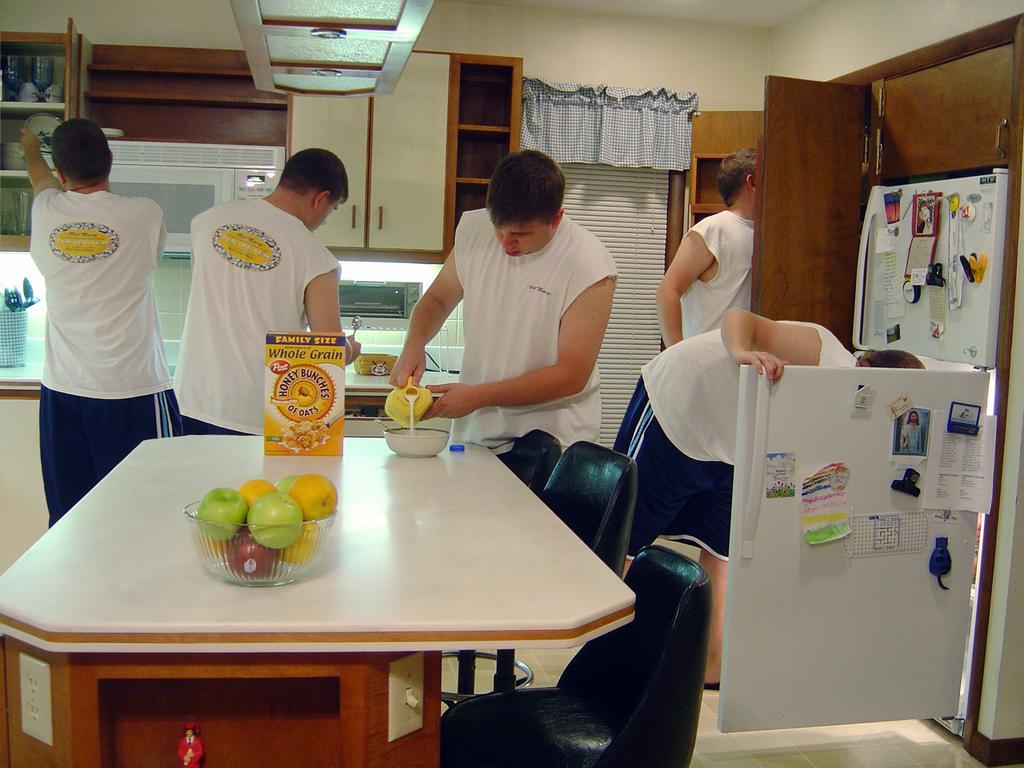In one or two sentences, can you explain what this image depicts? This image is taken inside a room. In the middle of the image there is a table and on top of that there is a bowl with fruits, a box with oats in it and a bowl with milk on the table. In the right side of the image there is a fridge with many stickers on it. In the background four men are working and there is a oven, cupboards, curtains walls and doors. At the top of the image there is a ceiling. 